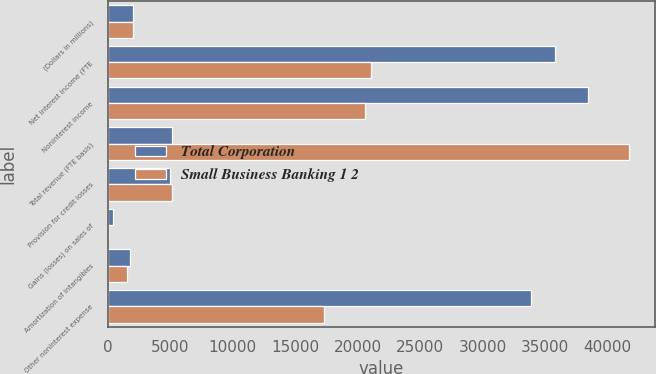Convert chart to OTSL. <chart><loc_0><loc_0><loc_500><loc_500><stacked_bar_chart><ecel><fcel>(Dollars in millions)<fcel>Net interest income (FTE<fcel>Noninterest income<fcel>Total revenue (FTE basis)<fcel>Provision for credit losses<fcel>Gains (losses) on sales of<fcel>Amortization of intangibles<fcel>Other noninterest expense<nl><fcel>Total Corporation<fcel>2006<fcel>35815<fcel>38432<fcel>5172<fcel>5010<fcel>443<fcel>1755<fcel>33842<nl><fcel>Small Business Banking 1 2<fcel>2006<fcel>21100<fcel>20591<fcel>41691<fcel>5172<fcel>1<fcel>1511<fcel>17319<nl></chart> 